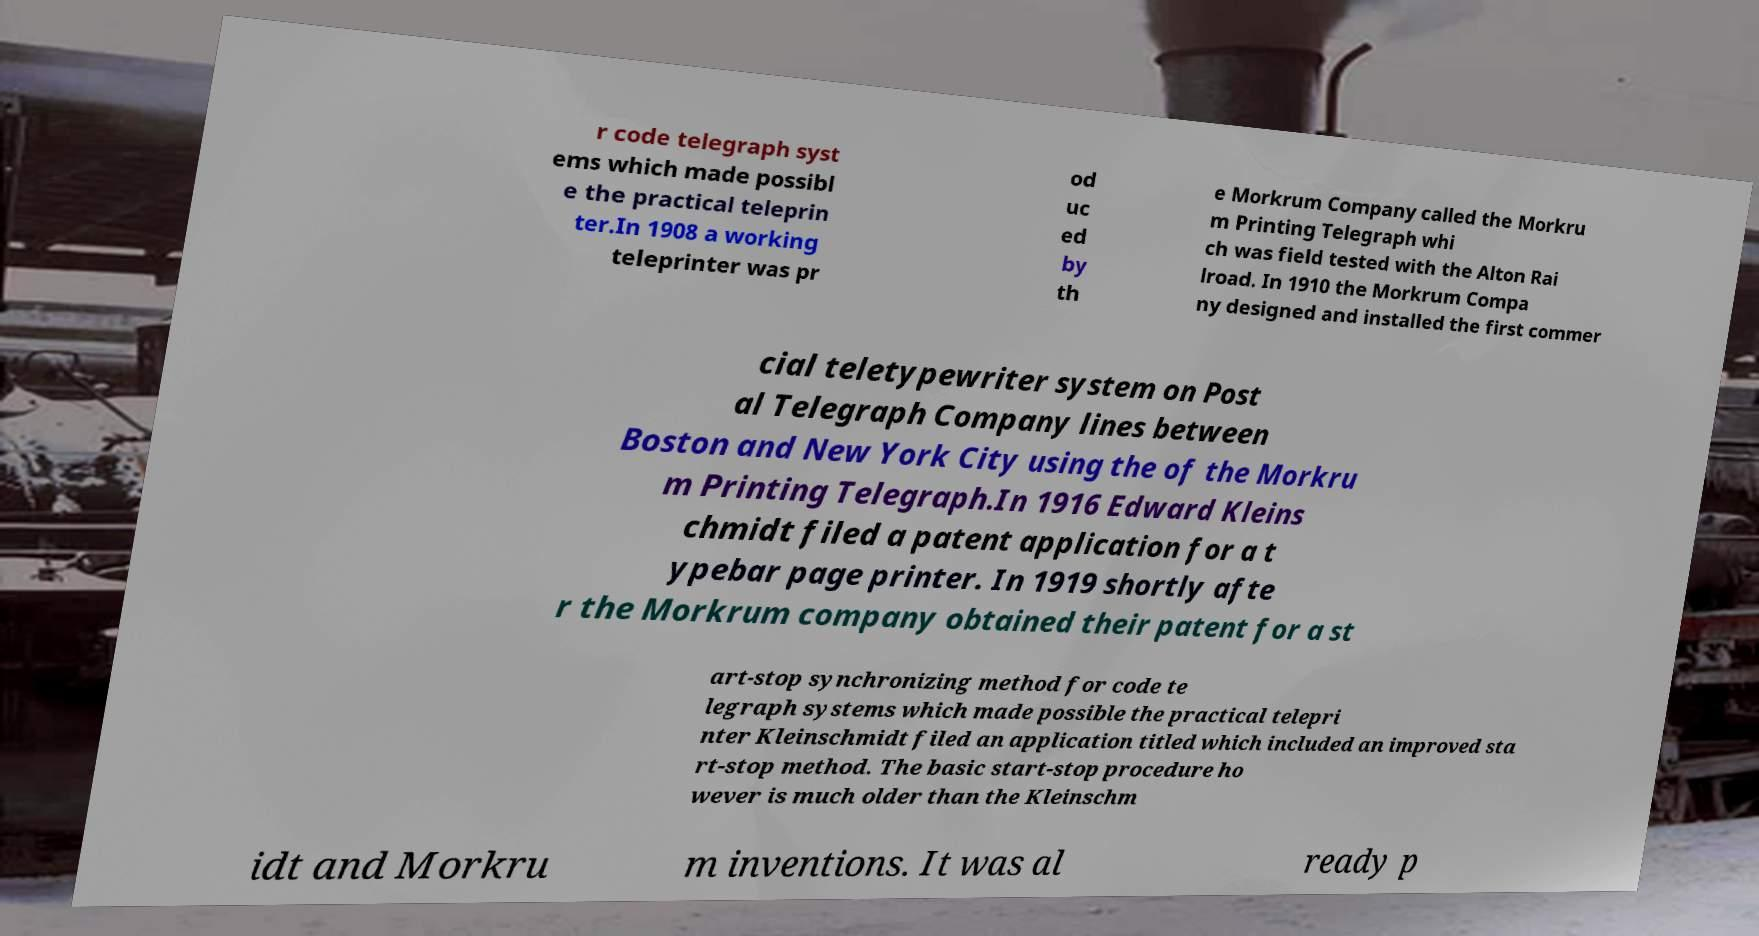Please read and relay the text visible in this image. What does it say? r code telegraph syst ems which made possibl e the practical teleprin ter.In 1908 a working teleprinter was pr od uc ed by th e Morkrum Company called the Morkru m Printing Telegraph whi ch was field tested with the Alton Rai lroad. In 1910 the Morkrum Compa ny designed and installed the first commer cial teletypewriter system on Post al Telegraph Company lines between Boston and New York City using the of the Morkru m Printing Telegraph.In 1916 Edward Kleins chmidt filed a patent application for a t ypebar page printer. In 1919 shortly afte r the Morkrum company obtained their patent for a st art-stop synchronizing method for code te legraph systems which made possible the practical telepri nter Kleinschmidt filed an application titled which included an improved sta rt-stop method. The basic start-stop procedure ho wever is much older than the Kleinschm idt and Morkru m inventions. It was al ready p 